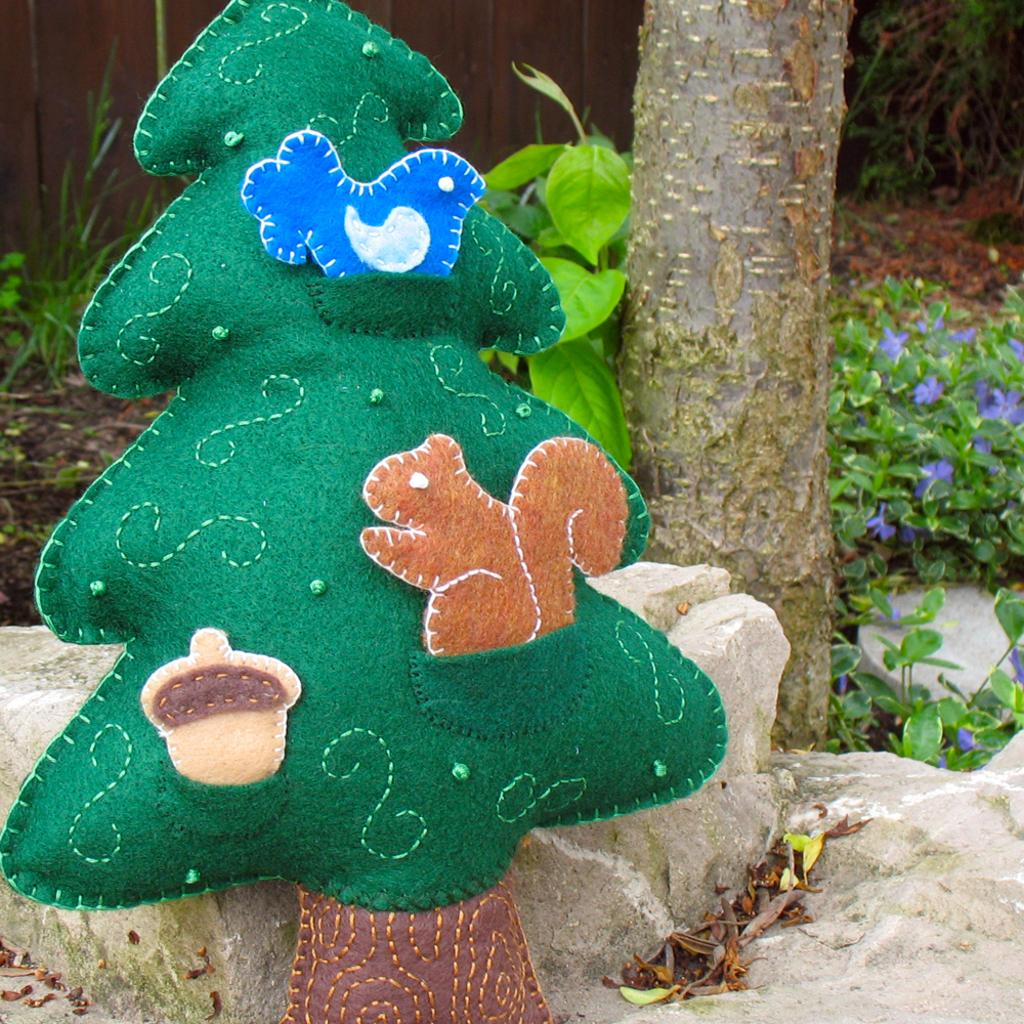What type of tree is present in the image? There is an artificial tree in the image. What can be seen in the background of the image? There are trees and plants in the background of the image. What size of writing can be seen on the tree in the image? There is no writing present on the tree in the image. Is there a fireman visible in the image? There is no fireman present in the image. 